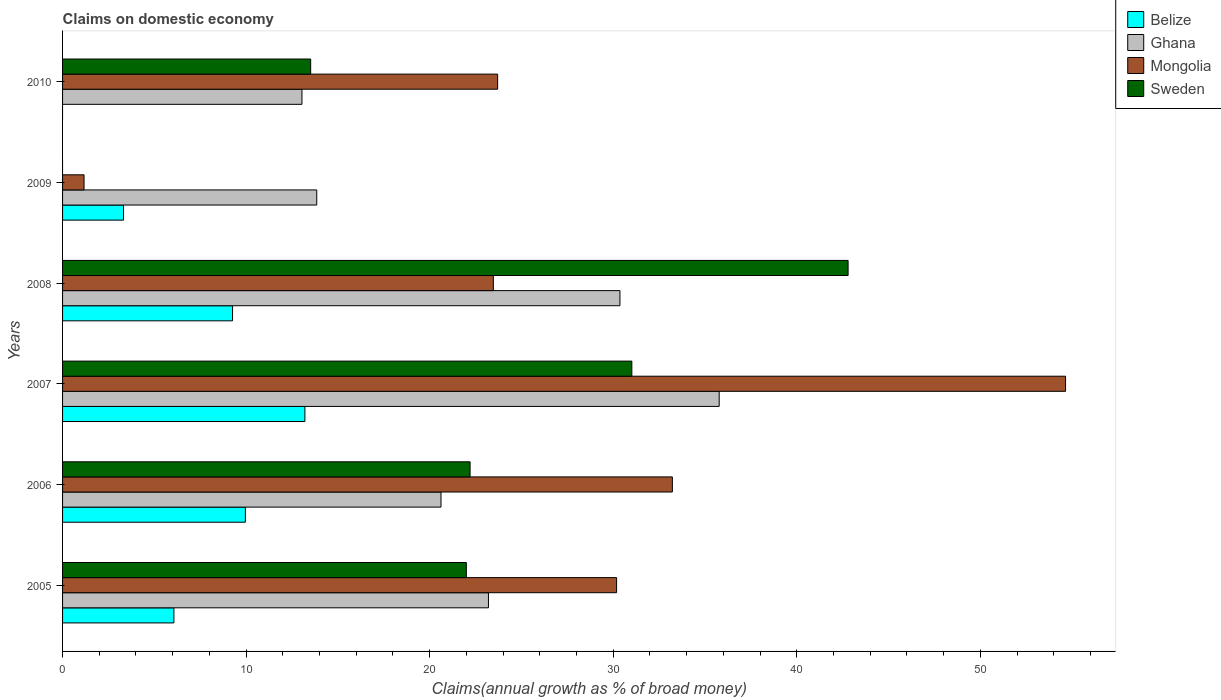How many different coloured bars are there?
Ensure brevity in your answer.  4. How many bars are there on the 2nd tick from the top?
Offer a very short reply. 3. How many bars are there on the 3rd tick from the bottom?
Your response must be concise. 4. What is the label of the 6th group of bars from the top?
Offer a terse response. 2005. In how many cases, is the number of bars for a given year not equal to the number of legend labels?
Ensure brevity in your answer.  2. What is the percentage of broad money claimed on domestic economy in Ghana in 2010?
Offer a terse response. 13.04. Across all years, what is the maximum percentage of broad money claimed on domestic economy in Mongolia?
Provide a succinct answer. 54.64. In which year was the percentage of broad money claimed on domestic economy in Belize maximum?
Your answer should be very brief. 2007. What is the total percentage of broad money claimed on domestic economy in Sweden in the graph?
Give a very brief answer. 131.53. What is the difference between the percentage of broad money claimed on domestic economy in Belize in 2005 and that in 2009?
Give a very brief answer. 2.74. What is the difference between the percentage of broad money claimed on domestic economy in Sweden in 2008 and the percentage of broad money claimed on domestic economy in Belize in 2007?
Your answer should be compact. 29.59. What is the average percentage of broad money claimed on domestic economy in Belize per year?
Your answer should be very brief. 6.97. In the year 2007, what is the difference between the percentage of broad money claimed on domestic economy in Mongolia and percentage of broad money claimed on domestic economy in Belize?
Provide a short and direct response. 41.44. What is the ratio of the percentage of broad money claimed on domestic economy in Sweden in 2006 to that in 2007?
Offer a very short reply. 0.72. Is the difference between the percentage of broad money claimed on domestic economy in Mongolia in 2005 and 2009 greater than the difference between the percentage of broad money claimed on domestic economy in Belize in 2005 and 2009?
Make the answer very short. Yes. What is the difference between the highest and the second highest percentage of broad money claimed on domestic economy in Sweden?
Give a very brief answer. 11.78. What is the difference between the highest and the lowest percentage of broad money claimed on domestic economy in Belize?
Your answer should be compact. 13.2. Is the sum of the percentage of broad money claimed on domestic economy in Belize in 2005 and 2009 greater than the maximum percentage of broad money claimed on domestic economy in Ghana across all years?
Give a very brief answer. No. Is it the case that in every year, the sum of the percentage of broad money claimed on domestic economy in Sweden and percentage of broad money claimed on domestic economy in Ghana is greater than the percentage of broad money claimed on domestic economy in Belize?
Provide a succinct answer. Yes. Are all the bars in the graph horizontal?
Give a very brief answer. Yes. Are the values on the major ticks of X-axis written in scientific E-notation?
Keep it short and to the point. No. How are the legend labels stacked?
Ensure brevity in your answer.  Vertical. What is the title of the graph?
Give a very brief answer. Claims on domestic economy. Does "Congo (Republic)" appear as one of the legend labels in the graph?
Ensure brevity in your answer.  No. What is the label or title of the X-axis?
Your answer should be very brief. Claims(annual growth as % of broad money). What is the Claims(annual growth as % of broad money) in Belize in 2005?
Make the answer very short. 6.07. What is the Claims(annual growth as % of broad money) of Ghana in 2005?
Make the answer very short. 23.2. What is the Claims(annual growth as % of broad money) of Mongolia in 2005?
Offer a terse response. 30.18. What is the Claims(annual growth as % of broad money) of Sweden in 2005?
Your answer should be very brief. 22. What is the Claims(annual growth as % of broad money) in Belize in 2006?
Your answer should be compact. 9.96. What is the Claims(annual growth as % of broad money) of Ghana in 2006?
Keep it short and to the point. 20.62. What is the Claims(annual growth as % of broad money) in Mongolia in 2006?
Provide a short and direct response. 33.22. What is the Claims(annual growth as % of broad money) in Sweden in 2006?
Ensure brevity in your answer.  22.2. What is the Claims(annual growth as % of broad money) of Belize in 2007?
Give a very brief answer. 13.2. What is the Claims(annual growth as % of broad money) of Ghana in 2007?
Offer a terse response. 35.77. What is the Claims(annual growth as % of broad money) of Mongolia in 2007?
Your answer should be compact. 54.64. What is the Claims(annual growth as % of broad money) in Sweden in 2007?
Offer a very short reply. 31.01. What is the Claims(annual growth as % of broad money) of Belize in 2008?
Your answer should be very brief. 9.26. What is the Claims(annual growth as % of broad money) in Ghana in 2008?
Offer a terse response. 30.37. What is the Claims(annual growth as % of broad money) in Mongolia in 2008?
Provide a succinct answer. 23.47. What is the Claims(annual growth as % of broad money) in Sweden in 2008?
Your response must be concise. 42.8. What is the Claims(annual growth as % of broad money) of Belize in 2009?
Keep it short and to the point. 3.32. What is the Claims(annual growth as % of broad money) in Ghana in 2009?
Give a very brief answer. 13.85. What is the Claims(annual growth as % of broad money) in Mongolia in 2009?
Ensure brevity in your answer.  1.17. What is the Claims(annual growth as % of broad money) in Belize in 2010?
Your answer should be very brief. 0. What is the Claims(annual growth as % of broad money) of Ghana in 2010?
Provide a short and direct response. 13.04. What is the Claims(annual growth as % of broad money) of Mongolia in 2010?
Keep it short and to the point. 23.7. What is the Claims(annual growth as % of broad money) of Sweden in 2010?
Your answer should be compact. 13.52. Across all years, what is the maximum Claims(annual growth as % of broad money) in Belize?
Give a very brief answer. 13.2. Across all years, what is the maximum Claims(annual growth as % of broad money) of Ghana?
Your answer should be very brief. 35.77. Across all years, what is the maximum Claims(annual growth as % of broad money) of Mongolia?
Your answer should be very brief. 54.64. Across all years, what is the maximum Claims(annual growth as % of broad money) of Sweden?
Make the answer very short. 42.8. Across all years, what is the minimum Claims(annual growth as % of broad money) in Belize?
Your answer should be very brief. 0. Across all years, what is the minimum Claims(annual growth as % of broad money) of Ghana?
Your answer should be very brief. 13.04. Across all years, what is the minimum Claims(annual growth as % of broad money) of Mongolia?
Your answer should be compact. 1.17. What is the total Claims(annual growth as % of broad money) of Belize in the graph?
Provide a short and direct response. 41.81. What is the total Claims(annual growth as % of broad money) of Ghana in the graph?
Offer a terse response. 136.85. What is the total Claims(annual growth as % of broad money) in Mongolia in the graph?
Your answer should be compact. 166.39. What is the total Claims(annual growth as % of broad money) of Sweden in the graph?
Keep it short and to the point. 131.53. What is the difference between the Claims(annual growth as % of broad money) of Belize in 2005 and that in 2006?
Your answer should be very brief. -3.89. What is the difference between the Claims(annual growth as % of broad money) in Ghana in 2005 and that in 2006?
Provide a short and direct response. 2.59. What is the difference between the Claims(annual growth as % of broad money) of Mongolia in 2005 and that in 2006?
Offer a terse response. -3.04. What is the difference between the Claims(annual growth as % of broad money) in Sweden in 2005 and that in 2006?
Your response must be concise. -0.2. What is the difference between the Claims(annual growth as % of broad money) of Belize in 2005 and that in 2007?
Provide a short and direct response. -7.14. What is the difference between the Claims(annual growth as % of broad money) in Ghana in 2005 and that in 2007?
Offer a very short reply. -12.57. What is the difference between the Claims(annual growth as % of broad money) in Mongolia in 2005 and that in 2007?
Keep it short and to the point. -24.46. What is the difference between the Claims(annual growth as % of broad money) of Sweden in 2005 and that in 2007?
Your answer should be compact. -9.02. What is the difference between the Claims(annual growth as % of broad money) in Belize in 2005 and that in 2008?
Provide a succinct answer. -3.19. What is the difference between the Claims(annual growth as % of broad money) of Ghana in 2005 and that in 2008?
Your answer should be compact. -7.16. What is the difference between the Claims(annual growth as % of broad money) in Mongolia in 2005 and that in 2008?
Your response must be concise. 6.71. What is the difference between the Claims(annual growth as % of broad money) of Sweden in 2005 and that in 2008?
Keep it short and to the point. -20.8. What is the difference between the Claims(annual growth as % of broad money) in Belize in 2005 and that in 2009?
Offer a very short reply. 2.74. What is the difference between the Claims(annual growth as % of broad money) of Ghana in 2005 and that in 2009?
Offer a terse response. 9.35. What is the difference between the Claims(annual growth as % of broad money) in Mongolia in 2005 and that in 2009?
Offer a terse response. 29.01. What is the difference between the Claims(annual growth as % of broad money) of Ghana in 2005 and that in 2010?
Your answer should be very brief. 10.16. What is the difference between the Claims(annual growth as % of broad money) in Mongolia in 2005 and that in 2010?
Your response must be concise. 6.48. What is the difference between the Claims(annual growth as % of broad money) in Sweden in 2005 and that in 2010?
Give a very brief answer. 8.48. What is the difference between the Claims(annual growth as % of broad money) in Belize in 2006 and that in 2007?
Offer a very short reply. -3.24. What is the difference between the Claims(annual growth as % of broad money) of Ghana in 2006 and that in 2007?
Your response must be concise. -15.16. What is the difference between the Claims(annual growth as % of broad money) of Mongolia in 2006 and that in 2007?
Give a very brief answer. -21.42. What is the difference between the Claims(annual growth as % of broad money) of Sweden in 2006 and that in 2007?
Provide a short and direct response. -8.81. What is the difference between the Claims(annual growth as % of broad money) in Belize in 2006 and that in 2008?
Your answer should be very brief. 0.7. What is the difference between the Claims(annual growth as % of broad money) in Ghana in 2006 and that in 2008?
Provide a succinct answer. -9.75. What is the difference between the Claims(annual growth as % of broad money) of Mongolia in 2006 and that in 2008?
Give a very brief answer. 9.75. What is the difference between the Claims(annual growth as % of broad money) in Sweden in 2006 and that in 2008?
Keep it short and to the point. -20.59. What is the difference between the Claims(annual growth as % of broad money) of Belize in 2006 and that in 2009?
Offer a terse response. 6.64. What is the difference between the Claims(annual growth as % of broad money) in Ghana in 2006 and that in 2009?
Offer a terse response. 6.77. What is the difference between the Claims(annual growth as % of broad money) in Mongolia in 2006 and that in 2009?
Make the answer very short. 32.05. What is the difference between the Claims(annual growth as % of broad money) of Ghana in 2006 and that in 2010?
Offer a very short reply. 7.58. What is the difference between the Claims(annual growth as % of broad money) in Mongolia in 2006 and that in 2010?
Provide a succinct answer. 9.52. What is the difference between the Claims(annual growth as % of broad money) in Sweden in 2006 and that in 2010?
Keep it short and to the point. 8.68. What is the difference between the Claims(annual growth as % of broad money) in Belize in 2007 and that in 2008?
Offer a very short reply. 3.94. What is the difference between the Claims(annual growth as % of broad money) in Ghana in 2007 and that in 2008?
Your answer should be compact. 5.41. What is the difference between the Claims(annual growth as % of broad money) of Mongolia in 2007 and that in 2008?
Provide a succinct answer. 31.18. What is the difference between the Claims(annual growth as % of broad money) in Sweden in 2007 and that in 2008?
Give a very brief answer. -11.78. What is the difference between the Claims(annual growth as % of broad money) of Belize in 2007 and that in 2009?
Give a very brief answer. 9.88. What is the difference between the Claims(annual growth as % of broad money) in Ghana in 2007 and that in 2009?
Make the answer very short. 21.92. What is the difference between the Claims(annual growth as % of broad money) of Mongolia in 2007 and that in 2009?
Provide a short and direct response. 53.47. What is the difference between the Claims(annual growth as % of broad money) of Ghana in 2007 and that in 2010?
Provide a short and direct response. 22.73. What is the difference between the Claims(annual growth as % of broad money) of Mongolia in 2007 and that in 2010?
Ensure brevity in your answer.  30.94. What is the difference between the Claims(annual growth as % of broad money) in Sweden in 2007 and that in 2010?
Offer a terse response. 17.5. What is the difference between the Claims(annual growth as % of broad money) in Belize in 2008 and that in 2009?
Offer a terse response. 5.94. What is the difference between the Claims(annual growth as % of broad money) of Ghana in 2008 and that in 2009?
Provide a succinct answer. 16.52. What is the difference between the Claims(annual growth as % of broad money) of Mongolia in 2008 and that in 2009?
Ensure brevity in your answer.  22.3. What is the difference between the Claims(annual growth as % of broad money) of Ghana in 2008 and that in 2010?
Offer a very short reply. 17.32. What is the difference between the Claims(annual growth as % of broad money) of Mongolia in 2008 and that in 2010?
Offer a terse response. -0.23. What is the difference between the Claims(annual growth as % of broad money) of Sweden in 2008 and that in 2010?
Your answer should be compact. 29.28. What is the difference between the Claims(annual growth as % of broad money) of Ghana in 2009 and that in 2010?
Keep it short and to the point. 0.81. What is the difference between the Claims(annual growth as % of broad money) of Mongolia in 2009 and that in 2010?
Your response must be concise. -22.53. What is the difference between the Claims(annual growth as % of broad money) in Belize in 2005 and the Claims(annual growth as % of broad money) in Ghana in 2006?
Your response must be concise. -14.55. What is the difference between the Claims(annual growth as % of broad money) of Belize in 2005 and the Claims(annual growth as % of broad money) of Mongolia in 2006?
Ensure brevity in your answer.  -27.16. What is the difference between the Claims(annual growth as % of broad money) in Belize in 2005 and the Claims(annual growth as % of broad money) in Sweden in 2006?
Your response must be concise. -16.14. What is the difference between the Claims(annual growth as % of broad money) of Ghana in 2005 and the Claims(annual growth as % of broad money) of Mongolia in 2006?
Offer a terse response. -10.02. What is the difference between the Claims(annual growth as % of broad money) in Ghana in 2005 and the Claims(annual growth as % of broad money) in Sweden in 2006?
Make the answer very short. 1. What is the difference between the Claims(annual growth as % of broad money) of Mongolia in 2005 and the Claims(annual growth as % of broad money) of Sweden in 2006?
Provide a succinct answer. 7.98. What is the difference between the Claims(annual growth as % of broad money) of Belize in 2005 and the Claims(annual growth as % of broad money) of Ghana in 2007?
Provide a short and direct response. -29.71. What is the difference between the Claims(annual growth as % of broad money) in Belize in 2005 and the Claims(annual growth as % of broad money) in Mongolia in 2007?
Your answer should be very brief. -48.58. What is the difference between the Claims(annual growth as % of broad money) of Belize in 2005 and the Claims(annual growth as % of broad money) of Sweden in 2007?
Give a very brief answer. -24.95. What is the difference between the Claims(annual growth as % of broad money) in Ghana in 2005 and the Claims(annual growth as % of broad money) in Mongolia in 2007?
Provide a succinct answer. -31.44. What is the difference between the Claims(annual growth as % of broad money) of Ghana in 2005 and the Claims(annual growth as % of broad money) of Sweden in 2007?
Keep it short and to the point. -7.81. What is the difference between the Claims(annual growth as % of broad money) of Mongolia in 2005 and the Claims(annual growth as % of broad money) of Sweden in 2007?
Provide a short and direct response. -0.83. What is the difference between the Claims(annual growth as % of broad money) of Belize in 2005 and the Claims(annual growth as % of broad money) of Ghana in 2008?
Offer a terse response. -24.3. What is the difference between the Claims(annual growth as % of broad money) in Belize in 2005 and the Claims(annual growth as % of broad money) in Mongolia in 2008?
Make the answer very short. -17.4. What is the difference between the Claims(annual growth as % of broad money) of Belize in 2005 and the Claims(annual growth as % of broad money) of Sweden in 2008?
Give a very brief answer. -36.73. What is the difference between the Claims(annual growth as % of broad money) of Ghana in 2005 and the Claims(annual growth as % of broad money) of Mongolia in 2008?
Provide a short and direct response. -0.27. What is the difference between the Claims(annual growth as % of broad money) of Ghana in 2005 and the Claims(annual growth as % of broad money) of Sweden in 2008?
Offer a terse response. -19.59. What is the difference between the Claims(annual growth as % of broad money) in Mongolia in 2005 and the Claims(annual growth as % of broad money) in Sweden in 2008?
Keep it short and to the point. -12.61. What is the difference between the Claims(annual growth as % of broad money) in Belize in 2005 and the Claims(annual growth as % of broad money) in Ghana in 2009?
Give a very brief answer. -7.78. What is the difference between the Claims(annual growth as % of broad money) of Belize in 2005 and the Claims(annual growth as % of broad money) of Mongolia in 2009?
Ensure brevity in your answer.  4.9. What is the difference between the Claims(annual growth as % of broad money) in Ghana in 2005 and the Claims(annual growth as % of broad money) in Mongolia in 2009?
Ensure brevity in your answer.  22.03. What is the difference between the Claims(annual growth as % of broad money) of Belize in 2005 and the Claims(annual growth as % of broad money) of Ghana in 2010?
Your answer should be compact. -6.98. What is the difference between the Claims(annual growth as % of broad money) in Belize in 2005 and the Claims(annual growth as % of broad money) in Mongolia in 2010?
Offer a very short reply. -17.64. What is the difference between the Claims(annual growth as % of broad money) in Belize in 2005 and the Claims(annual growth as % of broad money) in Sweden in 2010?
Your response must be concise. -7.45. What is the difference between the Claims(annual growth as % of broad money) in Ghana in 2005 and the Claims(annual growth as % of broad money) in Mongolia in 2010?
Ensure brevity in your answer.  -0.5. What is the difference between the Claims(annual growth as % of broad money) of Ghana in 2005 and the Claims(annual growth as % of broad money) of Sweden in 2010?
Your response must be concise. 9.69. What is the difference between the Claims(annual growth as % of broad money) in Mongolia in 2005 and the Claims(annual growth as % of broad money) in Sweden in 2010?
Make the answer very short. 16.67. What is the difference between the Claims(annual growth as % of broad money) in Belize in 2006 and the Claims(annual growth as % of broad money) in Ghana in 2007?
Ensure brevity in your answer.  -25.81. What is the difference between the Claims(annual growth as % of broad money) in Belize in 2006 and the Claims(annual growth as % of broad money) in Mongolia in 2007?
Ensure brevity in your answer.  -44.68. What is the difference between the Claims(annual growth as % of broad money) in Belize in 2006 and the Claims(annual growth as % of broad money) in Sweden in 2007?
Offer a terse response. -21.06. What is the difference between the Claims(annual growth as % of broad money) of Ghana in 2006 and the Claims(annual growth as % of broad money) of Mongolia in 2007?
Make the answer very short. -34.03. What is the difference between the Claims(annual growth as % of broad money) of Ghana in 2006 and the Claims(annual growth as % of broad money) of Sweden in 2007?
Provide a short and direct response. -10.4. What is the difference between the Claims(annual growth as % of broad money) of Mongolia in 2006 and the Claims(annual growth as % of broad money) of Sweden in 2007?
Keep it short and to the point. 2.21. What is the difference between the Claims(annual growth as % of broad money) of Belize in 2006 and the Claims(annual growth as % of broad money) of Ghana in 2008?
Your answer should be compact. -20.41. What is the difference between the Claims(annual growth as % of broad money) of Belize in 2006 and the Claims(annual growth as % of broad money) of Mongolia in 2008?
Your answer should be compact. -13.51. What is the difference between the Claims(annual growth as % of broad money) in Belize in 2006 and the Claims(annual growth as % of broad money) in Sweden in 2008?
Provide a succinct answer. -32.84. What is the difference between the Claims(annual growth as % of broad money) of Ghana in 2006 and the Claims(annual growth as % of broad money) of Mongolia in 2008?
Keep it short and to the point. -2.85. What is the difference between the Claims(annual growth as % of broad money) of Ghana in 2006 and the Claims(annual growth as % of broad money) of Sweden in 2008?
Ensure brevity in your answer.  -22.18. What is the difference between the Claims(annual growth as % of broad money) in Mongolia in 2006 and the Claims(annual growth as % of broad money) in Sweden in 2008?
Provide a short and direct response. -9.57. What is the difference between the Claims(annual growth as % of broad money) in Belize in 2006 and the Claims(annual growth as % of broad money) in Ghana in 2009?
Your answer should be compact. -3.89. What is the difference between the Claims(annual growth as % of broad money) in Belize in 2006 and the Claims(annual growth as % of broad money) in Mongolia in 2009?
Offer a terse response. 8.79. What is the difference between the Claims(annual growth as % of broad money) in Ghana in 2006 and the Claims(annual growth as % of broad money) in Mongolia in 2009?
Offer a very short reply. 19.45. What is the difference between the Claims(annual growth as % of broad money) of Belize in 2006 and the Claims(annual growth as % of broad money) of Ghana in 2010?
Ensure brevity in your answer.  -3.08. What is the difference between the Claims(annual growth as % of broad money) of Belize in 2006 and the Claims(annual growth as % of broad money) of Mongolia in 2010?
Give a very brief answer. -13.74. What is the difference between the Claims(annual growth as % of broad money) of Belize in 2006 and the Claims(annual growth as % of broad money) of Sweden in 2010?
Offer a terse response. -3.56. What is the difference between the Claims(annual growth as % of broad money) of Ghana in 2006 and the Claims(annual growth as % of broad money) of Mongolia in 2010?
Offer a very short reply. -3.09. What is the difference between the Claims(annual growth as % of broad money) of Ghana in 2006 and the Claims(annual growth as % of broad money) of Sweden in 2010?
Keep it short and to the point. 7.1. What is the difference between the Claims(annual growth as % of broad money) in Mongolia in 2006 and the Claims(annual growth as % of broad money) in Sweden in 2010?
Keep it short and to the point. 19.71. What is the difference between the Claims(annual growth as % of broad money) of Belize in 2007 and the Claims(annual growth as % of broad money) of Ghana in 2008?
Offer a very short reply. -17.16. What is the difference between the Claims(annual growth as % of broad money) of Belize in 2007 and the Claims(annual growth as % of broad money) of Mongolia in 2008?
Your response must be concise. -10.27. What is the difference between the Claims(annual growth as % of broad money) in Belize in 2007 and the Claims(annual growth as % of broad money) in Sweden in 2008?
Ensure brevity in your answer.  -29.59. What is the difference between the Claims(annual growth as % of broad money) in Ghana in 2007 and the Claims(annual growth as % of broad money) in Mongolia in 2008?
Your answer should be very brief. 12.3. What is the difference between the Claims(annual growth as % of broad money) of Ghana in 2007 and the Claims(annual growth as % of broad money) of Sweden in 2008?
Keep it short and to the point. -7.02. What is the difference between the Claims(annual growth as % of broad money) in Mongolia in 2007 and the Claims(annual growth as % of broad money) in Sweden in 2008?
Keep it short and to the point. 11.85. What is the difference between the Claims(annual growth as % of broad money) of Belize in 2007 and the Claims(annual growth as % of broad money) of Ghana in 2009?
Your response must be concise. -0.65. What is the difference between the Claims(annual growth as % of broad money) of Belize in 2007 and the Claims(annual growth as % of broad money) of Mongolia in 2009?
Your answer should be compact. 12.03. What is the difference between the Claims(annual growth as % of broad money) in Ghana in 2007 and the Claims(annual growth as % of broad money) in Mongolia in 2009?
Provide a short and direct response. 34.6. What is the difference between the Claims(annual growth as % of broad money) in Belize in 2007 and the Claims(annual growth as % of broad money) in Ghana in 2010?
Your response must be concise. 0.16. What is the difference between the Claims(annual growth as % of broad money) in Belize in 2007 and the Claims(annual growth as % of broad money) in Mongolia in 2010?
Provide a short and direct response. -10.5. What is the difference between the Claims(annual growth as % of broad money) of Belize in 2007 and the Claims(annual growth as % of broad money) of Sweden in 2010?
Keep it short and to the point. -0.32. What is the difference between the Claims(annual growth as % of broad money) of Ghana in 2007 and the Claims(annual growth as % of broad money) of Mongolia in 2010?
Your answer should be compact. 12.07. What is the difference between the Claims(annual growth as % of broad money) of Ghana in 2007 and the Claims(annual growth as % of broad money) of Sweden in 2010?
Keep it short and to the point. 22.26. What is the difference between the Claims(annual growth as % of broad money) in Mongolia in 2007 and the Claims(annual growth as % of broad money) in Sweden in 2010?
Ensure brevity in your answer.  41.13. What is the difference between the Claims(annual growth as % of broad money) of Belize in 2008 and the Claims(annual growth as % of broad money) of Ghana in 2009?
Ensure brevity in your answer.  -4.59. What is the difference between the Claims(annual growth as % of broad money) in Belize in 2008 and the Claims(annual growth as % of broad money) in Mongolia in 2009?
Offer a very short reply. 8.09. What is the difference between the Claims(annual growth as % of broad money) of Ghana in 2008 and the Claims(annual growth as % of broad money) of Mongolia in 2009?
Offer a very short reply. 29.2. What is the difference between the Claims(annual growth as % of broad money) in Belize in 2008 and the Claims(annual growth as % of broad money) in Ghana in 2010?
Make the answer very short. -3.78. What is the difference between the Claims(annual growth as % of broad money) of Belize in 2008 and the Claims(annual growth as % of broad money) of Mongolia in 2010?
Your answer should be compact. -14.44. What is the difference between the Claims(annual growth as % of broad money) in Belize in 2008 and the Claims(annual growth as % of broad money) in Sweden in 2010?
Your response must be concise. -4.26. What is the difference between the Claims(annual growth as % of broad money) in Ghana in 2008 and the Claims(annual growth as % of broad money) in Mongolia in 2010?
Offer a very short reply. 6.66. What is the difference between the Claims(annual growth as % of broad money) in Ghana in 2008 and the Claims(annual growth as % of broad money) in Sweden in 2010?
Keep it short and to the point. 16.85. What is the difference between the Claims(annual growth as % of broad money) of Mongolia in 2008 and the Claims(annual growth as % of broad money) of Sweden in 2010?
Make the answer very short. 9.95. What is the difference between the Claims(annual growth as % of broad money) in Belize in 2009 and the Claims(annual growth as % of broad money) in Ghana in 2010?
Offer a terse response. -9.72. What is the difference between the Claims(annual growth as % of broad money) in Belize in 2009 and the Claims(annual growth as % of broad money) in Mongolia in 2010?
Your answer should be very brief. -20.38. What is the difference between the Claims(annual growth as % of broad money) in Belize in 2009 and the Claims(annual growth as % of broad money) in Sweden in 2010?
Provide a short and direct response. -10.2. What is the difference between the Claims(annual growth as % of broad money) of Ghana in 2009 and the Claims(annual growth as % of broad money) of Mongolia in 2010?
Ensure brevity in your answer.  -9.85. What is the difference between the Claims(annual growth as % of broad money) of Ghana in 2009 and the Claims(annual growth as % of broad money) of Sweden in 2010?
Provide a short and direct response. 0.33. What is the difference between the Claims(annual growth as % of broad money) in Mongolia in 2009 and the Claims(annual growth as % of broad money) in Sweden in 2010?
Your answer should be very brief. -12.35. What is the average Claims(annual growth as % of broad money) of Belize per year?
Your answer should be compact. 6.97. What is the average Claims(annual growth as % of broad money) of Ghana per year?
Make the answer very short. 22.81. What is the average Claims(annual growth as % of broad money) of Mongolia per year?
Ensure brevity in your answer.  27.73. What is the average Claims(annual growth as % of broad money) of Sweden per year?
Provide a succinct answer. 21.92. In the year 2005, what is the difference between the Claims(annual growth as % of broad money) of Belize and Claims(annual growth as % of broad money) of Ghana?
Make the answer very short. -17.14. In the year 2005, what is the difference between the Claims(annual growth as % of broad money) of Belize and Claims(annual growth as % of broad money) of Mongolia?
Your answer should be compact. -24.12. In the year 2005, what is the difference between the Claims(annual growth as % of broad money) of Belize and Claims(annual growth as % of broad money) of Sweden?
Your response must be concise. -15.93. In the year 2005, what is the difference between the Claims(annual growth as % of broad money) of Ghana and Claims(annual growth as % of broad money) of Mongolia?
Provide a short and direct response. -6.98. In the year 2005, what is the difference between the Claims(annual growth as % of broad money) in Ghana and Claims(annual growth as % of broad money) in Sweden?
Offer a very short reply. 1.2. In the year 2005, what is the difference between the Claims(annual growth as % of broad money) of Mongolia and Claims(annual growth as % of broad money) of Sweden?
Provide a succinct answer. 8.19. In the year 2006, what is the difference between the Claims(annual growth as % of broad money) of Belize and Claims(annual growth as % of broad money) of Ghana?
Ensure brevity in your answer.  -10.66. In the year 2006, what is the difference between the Claims(annual growth as % of broad money) in Belize and Claims(annual growth as % of broad money) in Mongolia?
Give a very brief answer. -23.26. In the year 2006, what is the difference between the Claims(annual growth as % of broad money) in Belize and Claims(annual growth as % of broad money) in Sweden?
Provide a short and direct response. -12.24. In the year 2006, what is the difference between the Claims(annual growth as % of broad money) of Ghana and Claims(annual growth as % of broad money) of Mongolia?
Your response must be concise. -12.61. In the year 2006, what is the difference between the Claims(annual growth as % of broad money) in Ghana and Claims(annual growth as % of broad money) in Sweden?
Offer a very short reply. -1.58. In the year 2006, what is the difference between the Claims(annual growth as % of broad money) of Mongolia and Claims(annual growth as % of broad money) of Sweden?
Your answer should be compact. 11.02. In the year 2007, what is the difference between the Claims(annual growth as % of broad money) of Belize and Claims(annual growth as % of broad money) of Ghana?
Keep it short and to the point. -22.57. In the year 2007, what is the difference between the Claims(annual growth as % of broad money) in Belize and Claims(annual growth as % of broad money) in Mongolia?
Provide a short and direct response. -41.44. In the year 2007, what is the difference between the Claims(annual growth as % of broad money) in Belize and Claims(annual growth as % of broad money) in Sweden?
Your response must be concise. -17.81. In the year 2007, what is the difference between the Claims(annual growth as % of broad money) in Ghana and Claims(annual growth as % of broad money) in Mongolia?
Ensure brevity in your answer.  -18.87. In the year 2007, what is the difference between the Claims(annual growth as % of broad money) in Ghana and Claims(annual growth as % of broad money) in Sweden?
Ensure brevity in your answer.  4.76. In the year 2007, what is the difference between the Claims(annual growth as % of broad money) in Mongolia and Claims(annual growth as % of broad money) in Sweden?
Offer a terse response. 23.63. In the year 2008, what is the difference between the Claims(annual growth as % of broad money) of Belize and Claims(annual growth as % of broad money) of Ghana?
Offer a terse response. -21.11. In the year 2008, what is the difference between the Claims(annual growth as % of broad money) of Belize and Claims(annual growth as % of broad money) of Mongolia?
Keep it short and to the point. -14.21. In the year 2008, what is the difference between the Claims(annual growth as % of broad money) in Belize and Claims(annual growth as % of broad money) in Sweden?
Keep it short and to the point. -33.54. In the year 2008, what is the difference between the Claims(annual growth as % of broad money) of Ghana and Claims(annual growth as % of broad money) of Mongolia?
Your answer should be very brief. 6.9. In the year 2008, what is the difference between the Claims(annual growth as % of broad money) in Ghana and Claims(annual growth as % of broad money) in Sweden?
Offer a terse response. -12.43. In the year 2008, what is the difference between the Claims(annual growth as % of broad money) in Mongolia and Claims(annual growth as % of broad money) in Sweden?
Provide a short and direct response. -19.33. In the year 2009, what is the difference between the Claims(annual growth as % of broad money) of Belize and Claims(annual growth as % of broad money) of Ghana?
Provide a succinct answer. -10.53. In the year 2009, what is the difference between the Claims(annual growth as % of broad money) in Belize and Claims(annual growth as % of broad money) in Mongolia?
Keep it short and to the point. 2.15. In the year 2009, what is the difference between the Claims(annual growth as % of broad money) of Ghana and Claims(annual growth as % of broad money) of Mongolia?
Your answer should be very brief. 12.68. In the year 2010, what is the difference between the Claims(annual growth as % of broad money) in Ghana and Claims(annual growth as % of broad money) in Mongolia?
Your response must be concise. -10.66. In the year 2010, what is the difference between the Claims(annual growth as % of broad money) of Ghana and Claims(annual growth as % of broad money) of Sweden?
Offer a very short reply. -0.48. In the year 2010, what is the difference between the Claims(annual growth as % of broad money) of Mongolia and Claims(annual growth as % of broad money) of Sweden?
Provide a succinct answer. 10.19. What is the ratio of the Claims(annual growth as % of broad money) of Belize in 2005 to that in 2006?
Make the answer very short. 0.61. What is the ratio of the Claims(annual growth as % of broad money) in Ghana in 2005 to that in 2006?
Offer a terse response. 1.13. What is the ratio of the Claims(annual growth as % of broad money) of Mongolia in 2005 to that in 2006?
Make the answer very short. 0.91. What is the ratio of the Claims(annual growth as % of broad money) in Sweden in 2005 to that in 2006?
Your answer should be compact. 0.99. What is the ratio of the Claims(annual growth as % of broad money) in Belize in 2005 to that in 2007?
Provide a succinct answer. 0.46. What is the ratio of the Claims(annual growth as % of broad money) of Ghana in 2005 to that in 2007?
Your answer should be compact. 0.65. What is the ratio of the Claims(annual growth as % of broad money) in Mongolia in 2005 to that in 2007?
Your answer should be compact. 0.55. What is the ratio of the Claims(annual growth as % of broad money) in Sweden in 2005 to that in 2007?
Offer a very short reply. 0.71. What is the ratio of the Claims(annual growth as % of broad money) of Belize in 2005 to that in 2008?
Your answer should be compact. 0.66. What is the ratio of the Claims(annual growth as % of broad money) in Ghana in 2005 to that in 2008?
Make the answer very short. 0.76. What is the ratio of the Claims(annual growth as % of broad money) of Mongolia in 2005 to that in 2008?
Give a very brief answer. 1.29. What is the ratio of the Claims(annual growth as % of broad money) in Sweden in 2005 to that in 2008?
Keep it short and to the point. 0.51. What is the ratio of the Claims(annual growth as % of broad money) in Belize in 2005 to that in 2009?
Provide a succinct answer. 1.83. What is the ratio of the Claims(annual growth as % of broad money) in Ghana in 2005 to that in 2009?
Your answer should be very brief. 1.68. What is the ratio of the Claims(annual growth as % of broad money) of Mongolia in 2005 to that in 2009?
Make the answer very short. 25.79. What is the ratio of the Claims(annual growth as % of broad money) in Ghana in 2005 to that in 2010?
Keep it short and to the point. 1.78. What is the ratio of the Claims(annual growth as % of broad money) in Mongolia in 2005 to that in 2010?
Your answer should be very brief. 1.27. What is the ratio of the Claims(annual growth as % of broad money) of Sweden in 2005 to that in 2010?
Give a very brief answer. 1.63. What is the ratio of the Claims(annual growth as % of broad money) in Belize in 2006 to that in 2007?
Your answer should be very brief. 0.75. What is the ratio of the Claims(annual growth as % of broad money) in Ghana in 2006 to that in 2007?
Keep it short and to the point. 0.58. What is the ratio of the Claims(annual growth as % of broad money) of Mongolia in 2006 to that in 2007?
Your answer should be compact. 0.61. What is the ratio of the Claims(annual growth as % of broad money) of Sweden in 2006 to that in 2007?
Provide a succinct answer. 0.72. What is the ratio of the Claims(annual growth as % of broad money) in Belize in 2006 to that in 2008?
Keep it short and to the point. 1.08. What is the ratio of the Claims(annual growth as % of broad money) in Ghana in 2006 to that in 2008?
Provide a short and direct response. 0.68. What is the ratio of the Claims(annual growth as % of broad money) of Mongolia in 2006 to that in 2008?
Offer a very short reply. 1.42. What is the ratio of the Claims(annual growth as % of broad money) in Sweden in 2006 to that in 2008?
Ensure brevity in your answer.  0.52. What is the ratio of the Claims(annual growth as % of broad money) of Belize in 2006 to that in 2009?
Keep it short and to the point. 3. What is the ratio of the Claims(annual growth as % of broad money) in Ghana in 2006 to that in 2009?
Your response must be concise. 1.49. What is the ratio of the Claims(annual growth as % of broad money) in Mongolia in 2006 to that in 2009?
Make the answer very short. 28.39. What is the ratio of the Claims(annual growth as % of broad money) in Ghana in 2006 to that in 2010?
Your response must be concise. 1.58. What is the ratio of the Claims(annual growth as % of broad money) in Mongolia in 2006 to that in 2010?
Your response must be concise. 1.4. What is the ratio of the Claims(annual growth as % of broad money) in Sweden in 2006 to that in 2010?
Keep it short and to the point. 1.64. What is the ratio of the Claims(annual growth as % of broad money) of Belize in 2007 to that in 2008?
Your answer should be very brief. 1.43. What is the ratio of the Claims(annual growth as % of broad money) in Ghana in 2007 to that in 2008?
Offer a very short reply. 1.18. What is the ratio of the Claims(annual growth as % of broad money) in Mongolia in 2007 to that in 2008?
Provide a succinct answer. 2.33. What is the ratio of the Claims(annual growth as % of broad money) of Sweden in 2007 to that in 2008?
Give a very brief answer. 0.72. What is the ratio of the Claims(annual growth as % of broad money) of Belize in 2007 to that in 2009?
Ensure brevity in your answer.  3.97. What is the ratio of the Claims(annual growth as % of broad money) of Ghana in 2007 to that in 2009?
Your response must be concise. 2.58. What is the ratio of the Claims(annual growth as % of broad money) in Mongolia in 2007 to that in 2009?
Your answer should be compact. 46.69. What is the ratio of the Claims(annual growth as % of broad money) in Ghana in 2007 to that in 2010?
Offer a terse response. 2.74. What is the ratio of the Claims(annual growth as % of broad money) of Mongolia in 2007 to that in 2010?
Your answer should be compact. 2.31. What is the ratio of the Claims(annual growth as % of broad money) of Sweden in 2007 to that in 2010?
Ensure brevity in your answer.  2.29. What is the ratio of the Claims(annual growth as % of broad money) in Belize in 2008 to that in 2009?
Offer a very short reply. 2.79. What is the ratio of the Claims(annual growth as % of broad money) in Ghana in 2008 to that in 2009?
Your answer should be compact. 2.19. What is the ratio of the Claims(annual growth as % of broad money) in Mongolia in 2008 to that in 2009?
Ensure brevity in your answer.  20.05. What is the ratio of the Claims(annual growth as % of broad money) of Ghana in 2008 to that in 2010?
Ensure brevity in your answer.  2.33. What is the ratio of the Claims(annual growth as % of broad money) of Mongolia in 2008 to that in 2010?
Your response must be concise. 0.99. What is the ratio of the Claims(annual growth as % of broad money) of Sweden in 2008 to that in 2010?
Provide a short and direct response. 3.17. What is the ratio of the Claims(annual growth as % of broad money) in Ghana in 2009 to that in 2010?
Your response must be concise. 1.06. What is the ratio of the Claims(annual growth as % of broad money) in Mongolia in 2009 to that in 2010?
Provide a short and direct response. 0.05. What is the difference between the highest and the second highest Claims(annual growth as % of broad money) in Belize?
Your answer should be very brief. 3.24. What is the difference between the highest and the second highest Claims(annual growth as % of broad money) in Ghana?
Ensure brevity in your answer.  5.41. What is the difference between the highest and the second highest Claims(annual growth as % of broad money) of Mongolia?
Make the answer very short. 21.42. What is the difference between the highest and the second highest Claims(annual growth as % of broad money) of Sweden?
Keep it short and to the point. 11.78. What is the difference between the highest and the lowest Claims(annual growth as % of broad money) of Belize?
Your answer should be very brief. 13.2. What is the difference between the highest and the lowest Claims(annual growth as % of broad money) of Ghana?
Offer a very short reply. 22.73. What is the difference between the highest and the lowest Claims(annual growth as % of broad money) of Mongolia?
Give a very brief answer. 53.47. What is the difference between the highest and the lowest Claims(annual growth as % of broad money) of Sweden?
Your answer should be very brief. 42.8. 